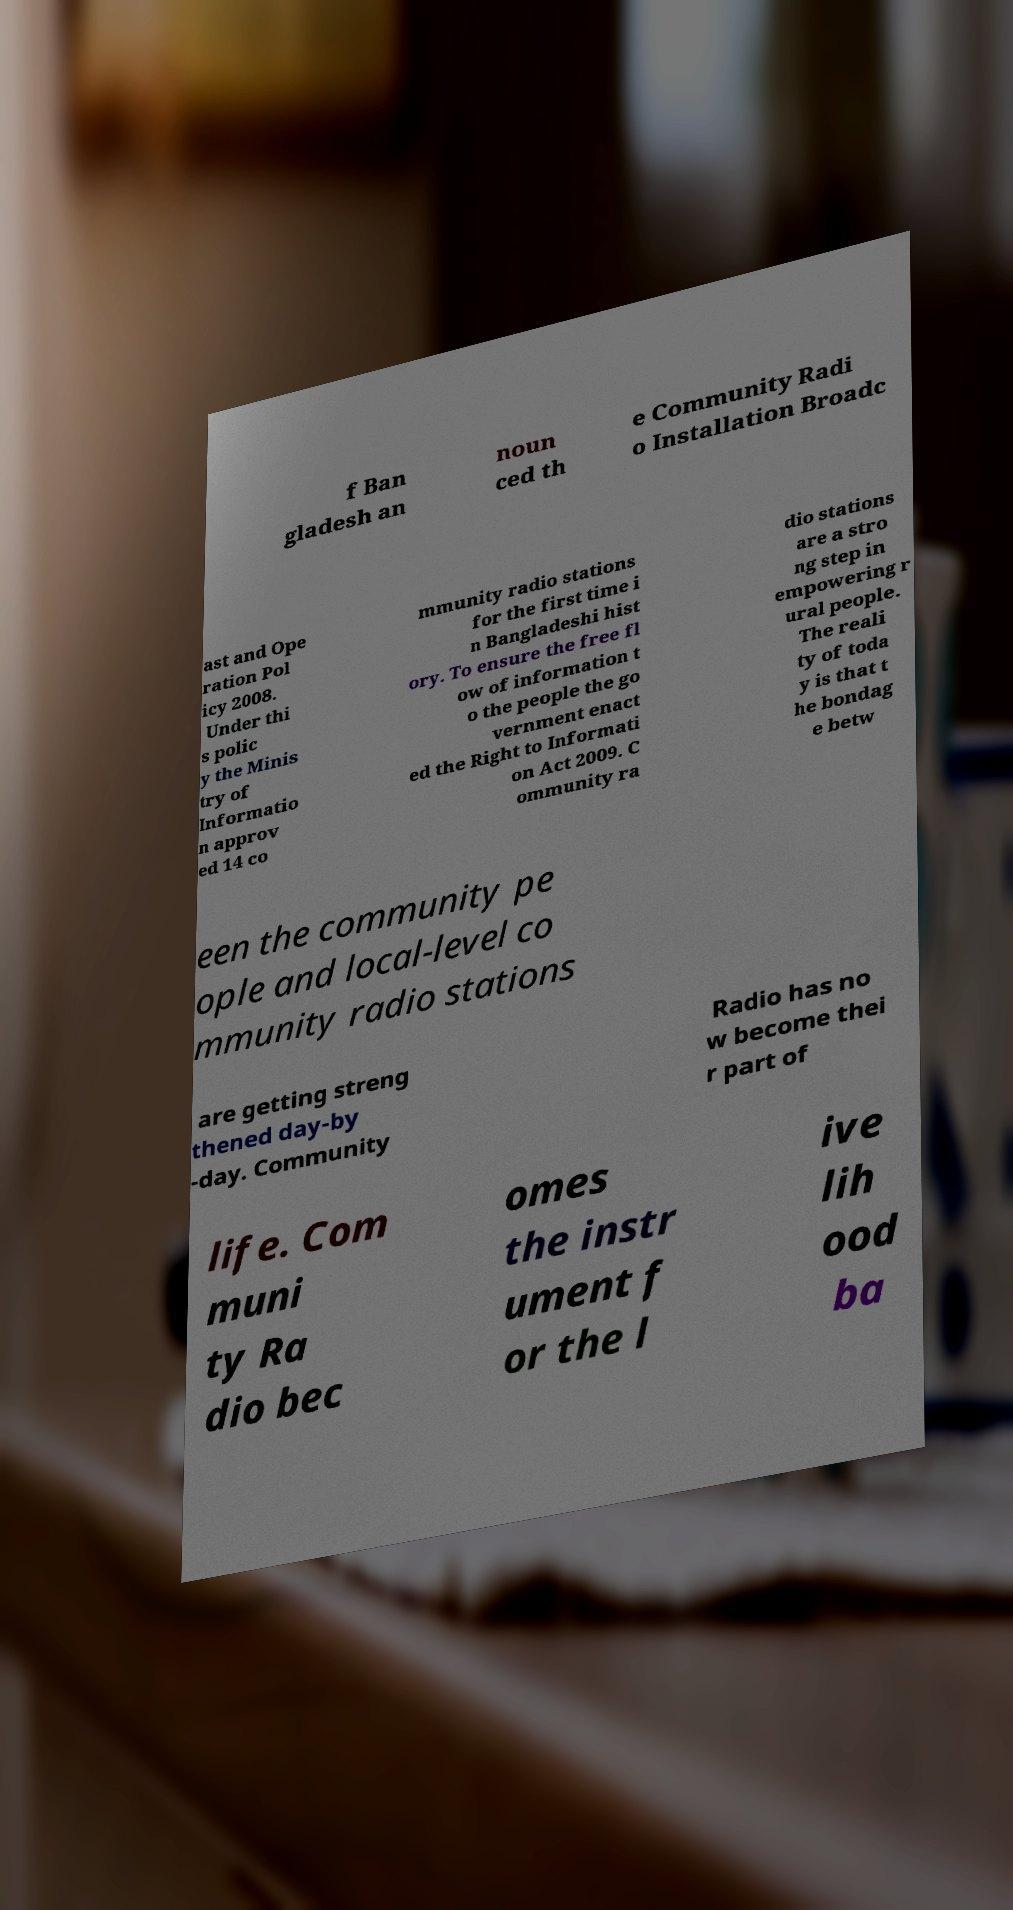Please read and relay the text visible in this image. What does it say? f Ban gladesh an noun ced th e Community Radi o Installation Broadc ast and Ope ration Pol icy 2008. Under thi s polic y the Minis try of Informatio n approv ed 14 co mmunity radio stations for the first time i n Bangladeshi hist ory. To ensure the free fl ow of information t o the people the go vernment enact ed the Right to Informati on Act 2009. C ommunity ra dio stations are a stro ng step in empowering r ural people. The reali ty of toda y is that t he bondag e betw een the community pe ople and local-level co mmunity radio stations are getting streng thened day-by -day. Community Radio has no w become thei r part of life. Com muni ty Ra dio bec omes the instr ument f or the l ive lih ood ba 